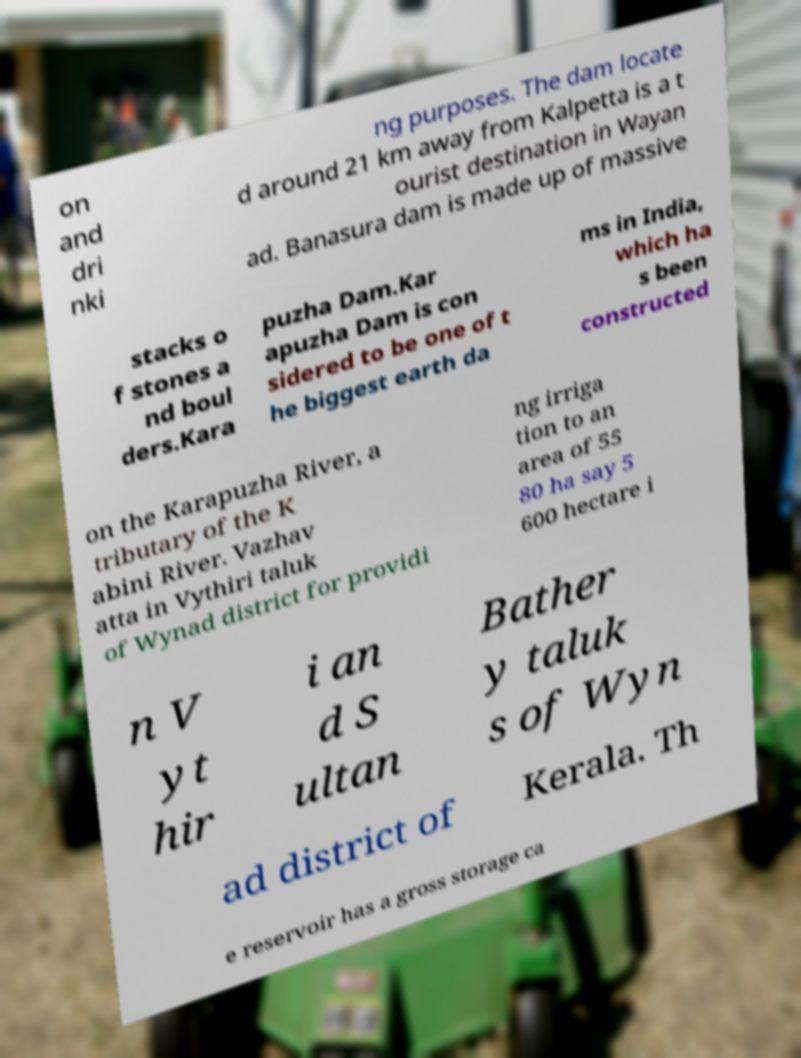Could you extract and type out the text from this image? on and dri nki ng purposes. The dam locate d around 21 km away from Kalpetta is a t ourist destination in Wayan ad. Banasura dam is made up of massive stacks o f stones a nd boul ders.Kara puzha Dam.Kar apuzha Dam is con sidered to be one of t he biggest earth da ms in India, which ha s been constructed on the Karapuzha River, a tributary of the K abini River. Vazhav atta in Vythiri taluk of Wynad district for providi ng irriga tion to an area of 55 80 ha say 5 600 hectare i n V yt hir i an d S ultan Bather y taluk s of Wyn ad district of Kerala. Th e reservoir has a gross storage ca 